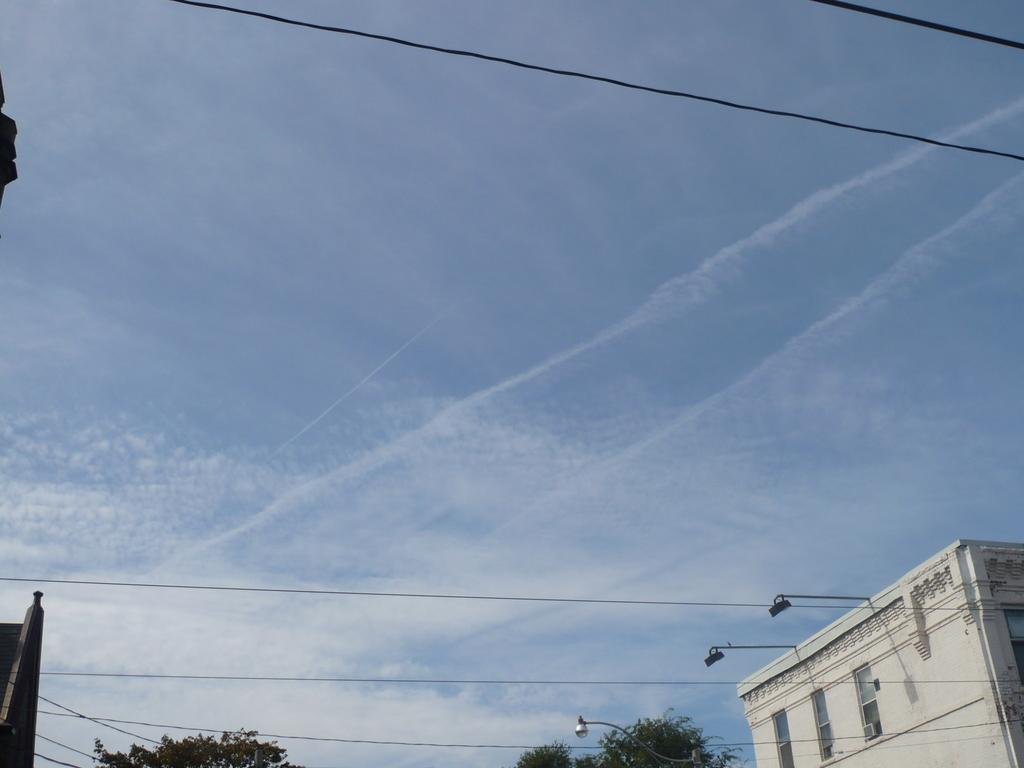What type of structures can be seen in the image? There are buildings in the image. the image. What other natural elements are present in the image? There are trees in the image. Are there any artificial light sources visible in the image? Yes, there are lights in the image. What else can be seen in the image that is related to infrastructure? There are wires in the image. What is visible at the top of the image? The sky is visible at the top of the image. Can you tell me how many loaves of bread are hanging from the wires in the image? There is no bread present in the image; it features buildings, trees, lights, and wires. What type of creature is shown interacting with the pig on the wires in the image? There is no pig or creature shown interacting with any object in the image. 